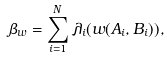<formula> <loc_0><loc_0><loc_500><loc_500>\beta _ { w } = \sum _ { i = 1 } ^ { N } \lambda _ { i } ( w ( A _ { i } , B _ { i } ) ) ,</formula> 